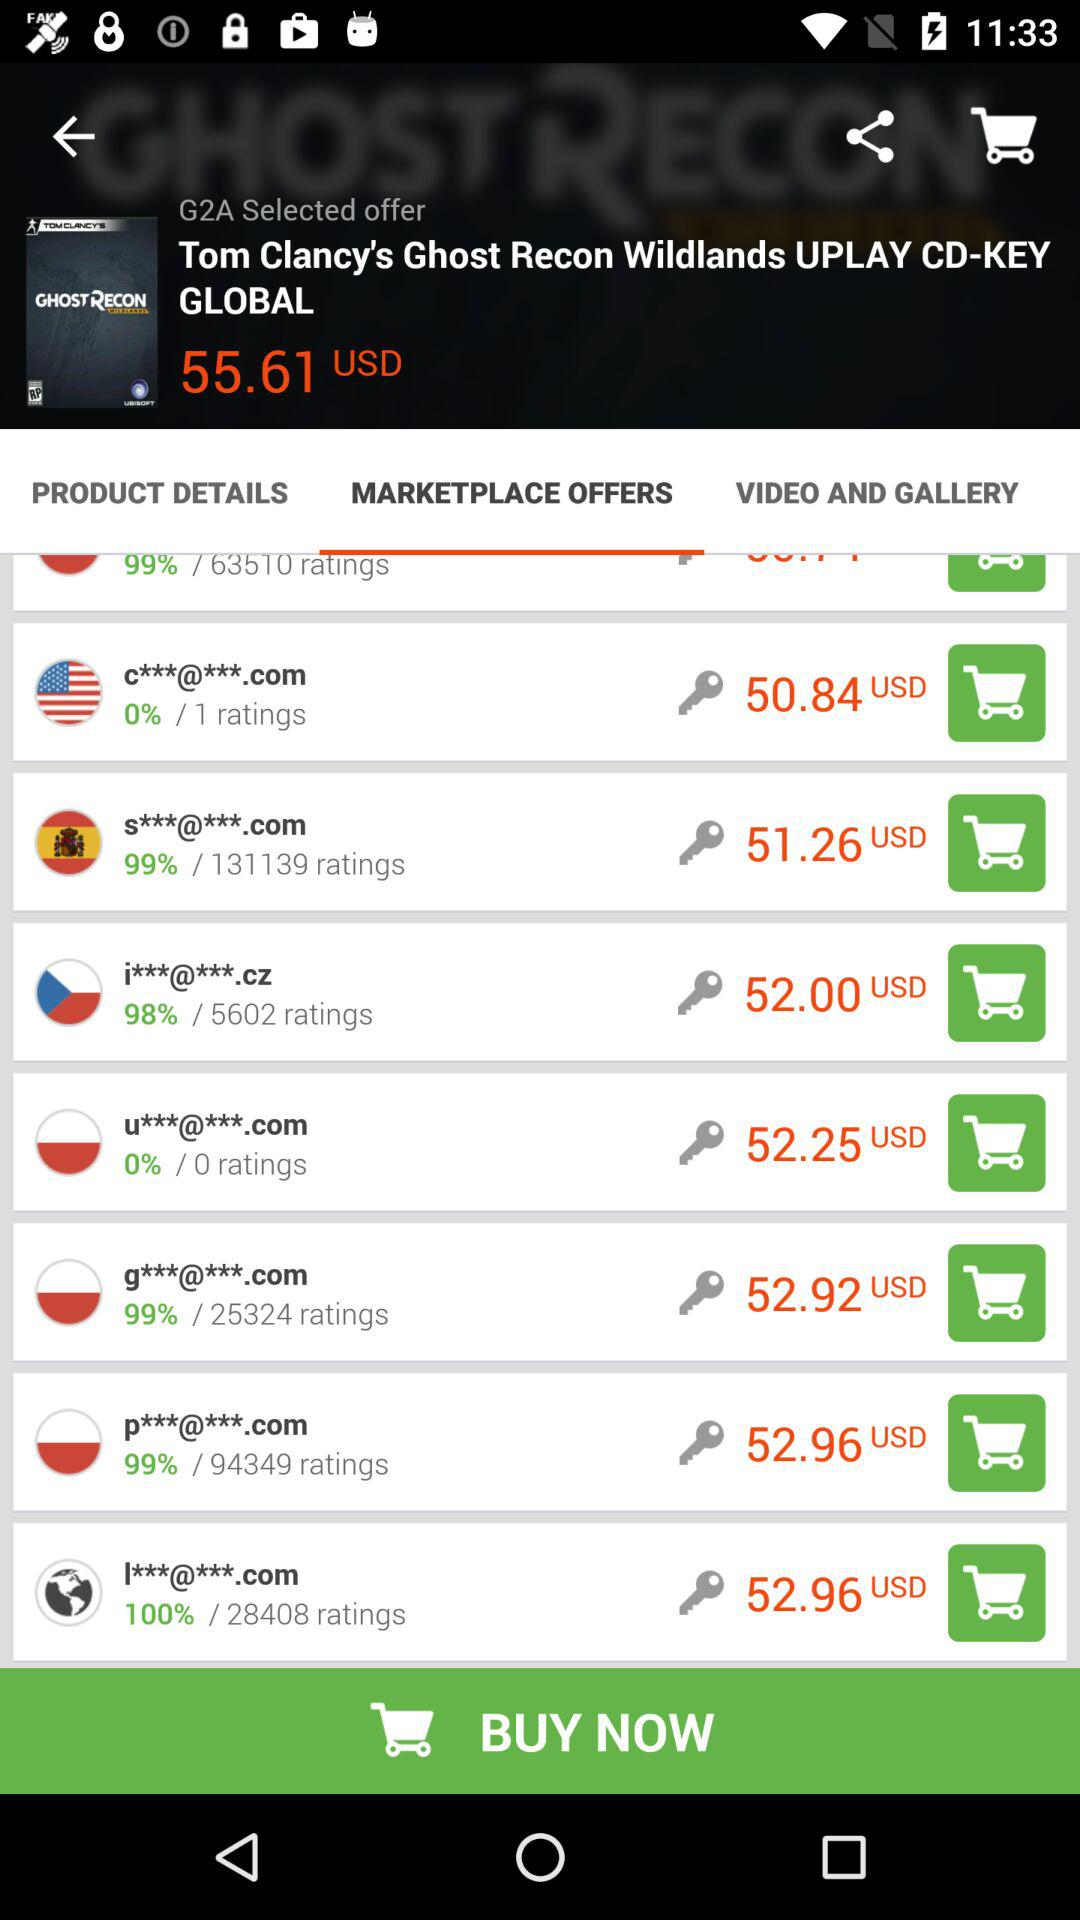Which tab is selected? The selected tab is "MARKETPLACE OFFERS". 